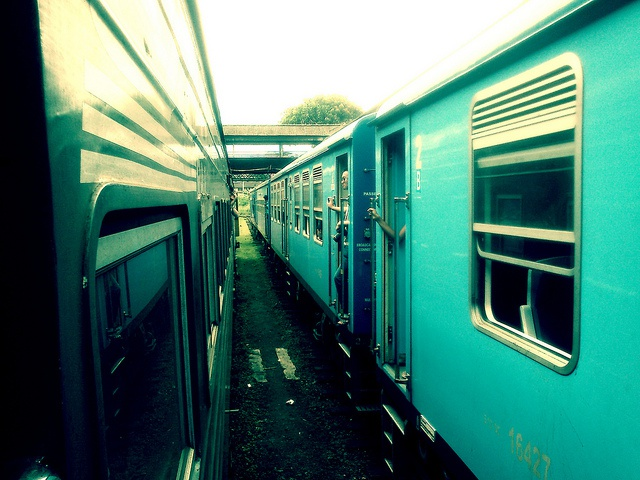Describe the objects in this image and their specific colors. I can see train in black, teal, and turquoise tones, train in black, lightyellow, khaki, and teal tones, chair in black and teal tones, people in black, teal, khaki, and darkblue tones, and people in black, teal, and green tones in this image. 